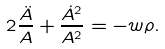<formula> <loc_0><loc_0><loc_500><loc_500>2 \frac { \ddot { A } } { A } + \frac { { \dot { A } } ^ { 2 } } { A ^ { 2 } } = - w \rho .</formula> 